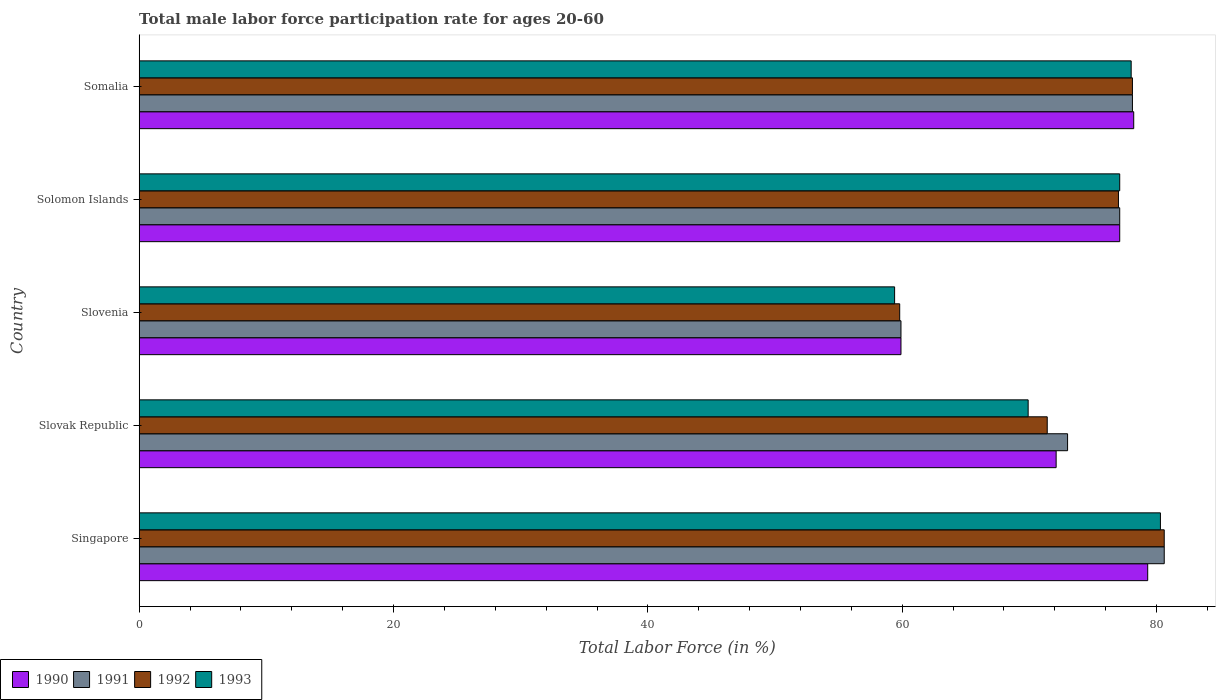How many different coloured bars are there?
Give a very brief answer. 4. Are the number of bars per tick equal to the number of legend labels?
Your answer should be very brief. Yes. Are the number of bars on each tick of the Y-axis equal?
Offer a terse response. Yes. How many bars are there on the 1st tick from the bottom?
Provide a succinct answer. 4. What is the label of the 4th group of bars from the top?
Your answer should be very brief. Slovak Republic. In how many cases, is the number of bars for a given country not equal to the number of legend labels?
Make the answer very short. 0. What is the male labor force participation rate in 1990 in Somalia?
Provide a short and direct response. 78.2. Across all countries, what is the maximum male labor force participation rate in 1993?
Give a very brief answer. 80.3. Across all countries, what is the minimum male labor force participation rate in 1990?
Your response must be concise. 59.9. In which country was the male labor force participation rate in 1990 maximum?
Keep it short and to the point. Singapore. In which country was the male labor force participation rate in 1990 minimum?
Give a very brief answer. Slovenia. What is the total male labor force participation rate in 1991 in the graph?
Ensure brevity in your answer.  368.7. What is the difference between the male labor force participation rate in 1992 in Slovak Republic and that in Solomon Islands?
Give a very brief answer. -5.6. What is the difference between the male labor force participation rate in 1991 in Solomon Islands and the male labor force participation rate in 1993 in Singapore?
Your response must be concise. -3.2. What is the average male labor force participation rate in 1990 per country?
Offer a very short reply. 73.32. What is the difference between the male labor force participation rate in 1993 and male labor force participation rate in 1990 in Somalia?
Offer a very short reply. -0.2. In how many countries, is the male labor force participation rate in 1993 greater than 56 %?
Your answer should be compact. 5. What is the ratio of the male labor force participation rate in 1992 in Singapore to that in Slovenia?
Keep it short and to the point. 1.35. What is the difference between the highest and the second highest male labor force participation rate in 1993?
Offer a terse response. 2.3. What is the difference between the highest and the lowest male labor force participation rate in 1992?
Your answer should be compact. 20.8. Is it the case that in every country, the sum of the male labor force participation rate in 1990 and male labor force participation rate in 1991 is greater than the sum of male labor force participation rate in 1993 and male labor force participation rate in 1992?
Provide a short and direct response. No. What does the 1st bar from the top in Somalia represents?
Your answer should be compact. 1993. What does the 2nd bar from the bottom in Slovak Republic represents?
Ensure brevity in your answer.  1991. How many bars are there?
Give a very brief answer. 20. Are all the bars in the graph horizontal?
Keep it short and to the point. Yes. What is the difference between two consecutive major ticks on the X-axis?
Ensure brevity in your answer.  20. Does the graph contain any zero values?
Make the answer very short. No. Does the graph contain grids?
Your response must be concise. No. What is the title of the graph?
Provide a succinct answer. Total male labor force participation rate for ages 20-60. What is the label or title of the X-axis?
Keep it short and to the point. Total Labor Force (in %). What is the Total Labor Force (in %) of 1990 in Singapore?
Provide a succinct answer. 79.3. What is the Total Labor Force (in %) in 1991 in Singapore?
Offer a terse response. 80.6. What is the Total Labor Force (in %) of 1992 in Singapore?
Provide a succinct answer. 80.6. What is the Total Labor Force (in %) of 1993 in Singapore?
Offer a terse response. 80.3. What is the Total Labor Force (in %) of 1990 in Slovak Republic?
Offer a terse response. 72.1. What is the Total Labor Force (in %) of 1992 in Slovak Republic?
Offer a very short reply. 71.4. What is the Total Labor Force (in %) of 1993 in Slovak Republic?
Offer a very short reply. 69.9. What is the Total Labor Force (in %) of 1990 in Slovenia?
Offer a very short reply. 59.9. What is the Total Labor Force (in %) in 1991 in Slovenia?
Give a very brief answer. 59.9. What is the Total Labor Force (in %) of 1992 in Slovenia?
Provide a succinct answer. 59.8. What is the Total Labor Force (in %) of 1993 in Slovenia?
Provide a short and direct response. 59.4. What is the Total Labor Force (in %) of 1990 in Solomon Islands?
Give a very brief answer. 77.1. What is the Total Labor Force (in %) in 1991 in Solomon Islands?
Offer a very short reply. 77.1. What is the Total Labor Force (in %) in 1993 in Solomon Islands?
Offer a terse response. 77.1. What is the Total Labor Force (in %) in 1990 in Somalia?
Offer a very short reply. 78.2. What is the Total Labor Force (in %) in 1991 in Somalia?
Give a very brief answer. 78.1. What is the Total Labor Force (in %) in 1992 in Somalia?
Your answer should be compact. 78.1. Across all countries, what is the maximum Total Labor Force (in %) in 1990?
Offer a terse response. 79.3. Across all countries, what is the maximum Total Labor Force (in %) in 1991?
Keep it short and to the point. 80.6. Across all countries, what is the maximum Total Labor Force (in %) in 1992?
Keep it short and to the point. 80.6. Across all countries, what is the maximum Total Labor Force (in %) in 1993?
Make the answer very short. 80.3. Across all countries, what is the minimum Total Labor Force (in %) of 1990?
Your answer should be very brief. 59.9. Across all countries, what is the minimum Total Labor Force (in %) in 1991?
Make the answer very short. 59.9. Across all countries, what is the minimum Total Labor Force (in %) of 1992?
Your answer should be compact. 59.8. Across all countries, what is the minimum Total Labor Force (in %) of 1993?
Your answer should be compact. 59.4. What is the total Total Labor Force (in %) of 1990 in the graph?
Your response must be concise. 366.6. What is the total Total Labor Force (in %) of 1991 in the graph?
Make the answer very short. 368.7. What is the total Total Labor Force (in %) in 1992 in the graph?
Ensure brevity in your answer.  366.9. What is the total Total Labor Force (in %) of 1993 in the graph?
Your answer should be very brief. 364.7. What is the difference between the Total Labor Force (in %) of 1991 in Singapore and that in Slovak Republic?
Make the answer very short. 7.6. What is the difference between the Total Labor Force (in %) of 1992 in Singapore and that in Slovak Republic?
Keep it short and to the point. 9.2. What is the difference between the Total Labor Force (in %) of 1993 in Singapore and that in Slovak Republic?
Your answer should be very brief. 10.4. What is the difference between the Total Labor Force (in %) of 1991 in Singapore and that in Slovenia?
Provide a short and direct response. 20.7. What is the difference between the Total Labor Force (in %) of 1992 in Singapore and that in Slovenia?
Give a very brief answer. 20.8. What is the difference between the Total Labor Force (in %) of 1993 in Singapore and that in Slovenia?
Make the answer very short. 20.9. What is the difference between the Total Labor Force (in %) in 1992 in Singapore and that in Somalia?
Give a very brief answer. 2.5. What is the difference between the Total Labor Force (in %) of 1990 in Slovak Republic and that in Solomon Islands?
Give a very brief answer. -5. What is the difference between the Total Labor Force (in %) of 1991 in Slovak Republic and that in Solomon Islands?
Keep it short and to the point. -4.1. What is the difference between the Total Labor Force (in %) of 1991 in Slovak Republic and that in Somalia?
Your response must be concise. -5.1. What is the difference between the Total Labor Force (in %) in 1990 in Slovenia and that in Solomon Islands?
Give a very brief answer. -17.2. What is the difference between the Total Labor Force (in %) of 1991 in Slovenia and that in Solomon Islands?
Ensure brevity in your answer.  -17.2. What is the difference between the Total Labor Force (in %) of 1992 in Slovenia and that in Solomon Islands?
Ensure brevity in your answer.  -17.2. What is the difference between the Total Labor Force (in %) in 1993 in Slovenia and that in Solomon Islands?
Offer a terse response. -17.7. What is the difference between the Total Labor Force (in %) in 1990 in Slovenia and that in Somalia?
Your response must be concise. -18.3. What is the difference between the Total Labor Force (in %) of 1991 in Slovenia and that in Somalia?
Keep it short and to the point. -18.2. What is the difference between the Total Labor Force (in %) in 1992 in Slovenia and that in Somalia?
Your answer should be very brief. -18.3. What is the difference between the Total Labor Force (in %) in 1993 in Slovenia and that in Somalia?
Offer a terse response. -18.6. What is the difference between the Total Labor Force (in %) in 1990 in Solomon Islands and that in Somalia?
Your answer should be compact. -1.1. What is the difference between the Total Labor Force (in %) in 1992 in Solomon Islands and that in Somalia?
Provide a short and direct response. -1.1. What is the difference between the Total Labor Force (in %) in 1990 in Singapore and the Total Labor Force (in %) in 1993 in Slovak Republic?
Make the answer very short. 9.4. What is the difference between the Total Labor Force (in %) in 1991 in Singapore and the Total Labor Force (in %) in 1993 in Slovak Republic?
Your response must be concise. 10.7. What is the difference between the Total Labor Force (in %) in 1992 in Singapore and the Total Labor Force (in %) in 1993 in Slovak Republic?
Keep it short and to the point. 10.7. What is the difference between the Total Labor Force (in %) in 1990 in Singapore and the Total Labor Force (in %) in 1992 in Slovenia?
Give a very brief answer. 19.5. What is the difference between the Total Labor Force (in %) in 1991 in Singapore and the Total Labor Force (in %) in 1992 in Slovenia?
Give a very brief answer. 20.8. What is the difference between the Total Labor Force (in %) in 1991 in Singapore and the Total Labor Force (in %) in 1993 in Slovenia?
Your response must be concise. 21.2. What is the difference between the Total Labor Force (in %) in 1992 in Singapore and the Total Labor Force (in %) in 1993 in Slovenia?
Keep it short and to the point. 21.2. What is the difference between the Total Labor Force (in %) of 1990 in Singapore and the Total Labor Force (in %) of 1991 in Solomon Islands?
Give a very brief answer. 2.2. What is the difference between the Total Labor Force (in %) of 1990 in Singapore and the Total Labor Force (in %) of 1992 in Solomon Islands?
Offer a very short reply. 2.3. What is the difference between the Total Labor Force (in %) of 1990 in Singapore and the Total Labor Force (in %) of 1993 in Solomon Islands?
Provide a succinct answer. 2.2. What is the difference between the Total Labor Force (in %) of 1990 in Singapore and the Total Labor Force (in %) of 1992 in Somalia?
Ensure brevity in your answer.  1.2. What is the difference between the Total Labor Force (in %) of 1990 in Singapore and the Total Labor Force (in %) of 1993 in Somalia?
Your response must be concise. 1.3. What is the difference between the Total Labor Force (in %) of 1991 in Singapore and the Total Labor Force (in %) of 1992 in Somalia?
Keep it short and to the point. 2.5. What is the difference between the Total Labor Force (in %) of 1992 in Singapore and the Total Labor Force (in %) of 1993 in Somalia?
Your answer should be very brief. 2.6. What is the difference between the Total Labor Force (in %) in 1990 in Slovak Republic and the Total Labor Force (in %) in 1991 in Slovenia?
Ensure brevity in your answer.  12.2. What is the difference between the Total Labor Force (in %) of 1991 in Slovak Republic and the Total Labor Force (in %) of 1993 in Slovenia?
Keep it short and to the point. 13.6. What is the difference between the Total Labor Force (in %) in 1992 in Slovak Republic and the Total Labor Force (in %) in 1993 in Slovenia?
Offer a terse response. 12. What is the difference between the Total Labor Force (in %) of 1990 in Slovak Republic and the Total Labor Force (in %) of 1992 in Solomon Islands?
Keep it short and to the point. -4.9. What is the difference between the Total Labor Force (in %) in 1990 in Slovak Republic and the Total Labor Force (in %) in 1993 in Solomon Islands?
Make the answer very short. -5. What is the difference between the Total Labor Force (in %) in 1991 in Slovak Republic and the Total Labor Force (in %) in 1992 in Solomon Islands?
Your answer should be very brief. -4. What is the difference between the Total Labor Force (in %) in 1990 in Slovak Republic and the Total Labor Force (in %) in 1993 in Somalia?
Your answer should be compact. -5.9. What is the difference between the Total Labor Force (in %) in 1992 in Slovak Republic and the Total Labor Force (in %) in 1993 in Somalia?
Give a very brief answer. -6.6. What is the difference between the Total Labor Force (in %) in 1990 in Slovenia and the Total Labor Force (in %) in 1991 in Solomon Islands?
Give a very brief answer. -17.2. What is the difference between the Total Labor Force (in %) of 1990 in Slovenia and the Total Labor Force (in %) of 1992 in Solomon Islands?
Keep it short and to the point. -17.1. What is the difference between the Total Labor Force (in %) of 1990 in Slovenia and the Total Labor Force (in %) of 1993 in Solomon Islands?
Provide a succinct answer. -17.2. What is the difference between the Total Labor Force (in %) of 1991 in Slovenia and the Total Labor Force (in %) of 1992 in Solomon Islands?
Your answer should be compact. -17.1. What is the difference between the Total Labor Force (in %) of 1991 in Slovenia and the Total Labor Force (in %) of 1993 in Solomon Islands?
Offer a terse response. -17.2. What is the difference between the Total Labor Force (in %) in 1992 in Slovenia and the Total Labor Force (in %) in 1993 in Solomon Islands?
Offer a very short reply. -17.3. What is the difference between the Total Labor Force (in %) in 1990 in Slovenia and the Total Labor Force (in %) in 1991 in Somalia?
Your answer should be very brief. -18.2. What is the difference between the Total Labor Force (in %) in 1990 in Slovenia and the Total Labor Force (in %) in 1992 in Somalia?
Provide a succinct answer. -18.2. What is the difference between the Total Labor Force (in %) in 1990 in Slovenia and the Total Labor Force (in %) in 1993 in Somalia?
Offer a terse response. -18.1. What is the difference between the Total Labor Force (in %) in 1991 in Slovenia and the Total Labor Force (in %) in 1992 in Somalia?
Ensure brevity in your answer.  -18.2. What is the difference between the Total Labor Force (in %) in 1991 in Slovenia and the Total Labor Force (in %) in 1993 in Somalia?
Provide a short and direct response. -18.1. What is the difference between the Total Labor Force (in %) in 1992 in Slovenia and the Total Labor Force (in %) in 1993 in Somalia?
Make the answer very short. -18.2. What is the difference between the Total Labor Force (in %) in 1990 in Solomon Islands and the Total Labor Force (in %) in 1991 in Somalia?
Make the answer very short. -1. What is the difference between the Total Labor Force (in %) in 1990 in Solomon Islands and the Total Labor Force (in %) in 1992 in Somalia?
Keep it short and to the point. -1. What is the difference between the Total Labor Force (in %) in 1992 in Solomon Islands and the Total Labor Force (in %) in 1993 in Somalia?
Offer a very short reply. -1. What is the average Total Labor Force (in %) in 1990 per country?
Keep it short and to the point. 73.32. What is the average Total Labor Force (in %) in 1991 per country?
Give a very brief answer. 73.74. What is the average Total Labor Force (in %) of 1992 per country?
Offer a very short reply. 73.38. What is the average Total Labor Force (in %) of 1993 per country?
Provide a succinct answer. 72.94. What is the difference between the Total Labor Force (in %) of 1990 and Total Labor Force (in %) of 1992 in Singapore?
Make the answer very short. -1.3. What is the difference between the Total Labor Force (in %) in 1991 and Total Labor Force (in %) in 1992 in Singapore?
Provide a short and direct response. 0. What is the difference between the Total Labor Force (in %) of 1992 and Total Labor Force (in %) of 1993 in Singapore?
Make the answer very short. 0.3. What is the difference between the Total Labor Force (in %) of 1990 and Total Labor Force (in %) of 1993 in Slovak Republic?
Give a very brief answer. 2.2. What is the difference between the Total Labor Force (in %) in 1991 and Total Labor Force (in %) in 1992 in Slovak Republic?
Make the answer very short. 1.6. What is the difference between the Total Labor Force (in %) of 1991 and Total Labor Force (in %) of 1993 in Slovak Republic?
Ensure brevity in your answer.  3.1. What is the difference between the Total Labor Force (in %) of 1992 and Total Labor Force (in %) of 1993 in Slovak Republic?
Your response must be concise. 1.5. What is the difference between the Total Labor Force (in %) in 1990 and Total Labor Force (in %) in 1991 in Slovenia?
Provide a succinct answer. 0. What is the difference between the Total Labor Force (in %) of 1990 and Total Labor Force (in %) of 1992 in Slovenia?
Keep it short and to the point. 0.1. What is the difference between the Total Labor Force (in %) in 1991 and Total Labor Force (in %) in 1992 in Slovenia?
Your response must be concise. 0.1. What is the difference between the Total Labor Force (in %) in 1990 and Total Labor Force (in %) in 1991 in Solomon Islands?
Your answer should be very brief. 0. What is the difference between the Total Labor Force (in %) in 1990 and Total Labor Force (in %) in 1992 in Solomon Islands?
Your answer should be very brief. 0.1. What is the difference between the Total Labor Force (in %) of 1990 and Total Labor Force (in %) of 1993 in Solomon Islands?
Your answer should be very brief. 0. What is the difference between the Total Labor Force (in %) in 1991 and Total Labor Force (in %) in 1992 in Solomon Islands?
Provide a succinct answer. 0.1. What is the difference between the Total Labor Force (in %) of 1991 and Total Labor Force (in %) of 1993 in Solomon Islands?
Offer a very short reply. 0. What is the difference between the Total Labor Force (in %) in 1990 and Total Labor Force (in %) in 1991 in Somalia?
Provide a short and direct response. 0.1. What is the difference between the Total Labor Force (in %) in 1990 and Total Labor Force (in %) in 1993 in Somalia?
Offer a terse response. 0.2. What is the difference between the Total Labor Force (in %) in 1991 and Total Labor Force (in %) in 1993 in Somalia?
Your answer should be compact. 0.1. What is the difference between the Total Labor Force (in %) of 1992 and Total Labor Force (in %) of 1993 in Somalia?
Give a very brief answer. 0.1. What is the ratio of the Total Labor Force (in %) of 1990 in Singapore to that in Slovak Republic?
Offer a terse response. 1.1. What is the ratio of the Total Labor Force (in %) in 1991 in Singapore to that in Slovak Republic?
Your answer should be compact. 1.1. What is the ratio of the Total Labor Force (in %) of 1992 in Singapore to that in Slovak Republic?
Provide a succinct answer. 1.13. What is the ratio of the Total Labor Force (in %) in 1993 in Singapore to that in Slovak Republic?
Your answer should be very brief. 1.15. What is the ratio of the Total Labor Force (in %) of 1990 in Singapore to that in Slovenia?
Provide a short and direct response. 1.32. What is the ratio of the Total Labor Force (in %) of 1991 in Singapore to that in Slovenia?
Give a very brief answer. 1.35. What is the ratio of the Total Labor Force (in %) in 1992 in Singapore to that in Slovenia?
Offer a very short reply. 1.35. What is the ratio of the Total Labor Force (in %) of 1993 in Singapore to that in Slovenia?
Give a very brief answer. 1.35. What is the ratio of the Total Labor Force (in %) in 1990 in Singapore to that in Solomon Islands?
Make the answer very short. 1.03. What is the ratio of the Total Labor Force (in %) in 1991 in Singapore to that in Solomon Islands?
Make the answer very short. 1.05. What is the ratio of the Total Labor Force (in %) in 1992 in Singapore to that in Solomon Islands?
Your answer should be compact. 1.05. What is the ratio of the Total Labor Force (in %) in 1993 in Singapore to that in Solomon Islands?
Keep it short and to the point. 1.04. What is the ratio of the Total Labor Force (in %) in 1990 in Singapore to that in Somalia?
Offer a very short reply. 1.01. What is the ratio of the Total Labor Force (in %) in 1991 in Singapore to that in Somalia?
Provide a succinct answer. 1.03. What is the ratio of the Total Labor Force (in %) of 1992 in Singapore to that in Somalia?
Keep it short and to the point. 1.03. What is the ratio of the Total Labor Force (in %) of 1993 in Singapore to that in Somalia?
Offer a terse response. 1.03. What is the ratio of the Total Labor Force (in %) in 1990 in Slovak Republic to that in Slovenia?
Your answer should be compact. 1.2. What is the ratio of the Total Labor Force (in %) in 1991 in Slovak Republic to that in Slovenia?
Keep it short and to the point. 1.22. What is the ratio of the Total Labor Force (in %) of 1992 in Slovak Republic to that in Slovenia?
Provide a succinct answer. 1.19. What is the ratio of the Total Labor Force (in %) of 1993 in Slovak Republic to that in Slovenia?
Your response must be concise. 1.18. What is the ratio of the Total Labor Force (in %) in 1990 in Slovak Republic to that in Solomon Islands?
Offer a very short reply. 0.94. What is the ratio of the Total Labor Force (in %) in 1991 in Slovak Republic to that in Solomon Islands?
Keep it short and to the point. 0.95. What is the ratio of the Total Labor Force (in %) in 1992 in Slovak Republic to that in Solomon Islands?
Ensure brevity in your answer.  0.93. What is the ratio of the Total Labor Force (in %) of 1993 in Slovak Republic to that in Solomon Islands?
Your answer should be compact. 0.91. What is the ratio of the Total Labor Force (in %) of 1990 in Slovak Republic to that in Somalia?
Your answer should be very brief. 0.92. What is the ratio of the Total Labor Force (in %) in 1991 in Slovak Republic to that in Somalia?
Provide a short and direct response. 0.93. What is the ratio of the Total Labor Force (in %) of 1992 in Slovak Republic to that in Somalia?
Ensure brevity in your answer.  0.91. What is the ratio of the Total Labor Force (in %) in 1993 in Slovak Republic to that in Somalia?
Offer a very short reply. 0.9. What is the ratio of the Total Labor Force (in %) in 1990 in Slovenia to that in Solomon Islands?
Your response must be concise. 0.78. What is the ratio of the Total Labor Force (in %) of 1991 in Slovenia to that in Solomon Islands?
Offer a very short reply. 0.78. What is the ratio of the Total Labor Force (in %) in 1992 in Slovenia to that in Solomon Islands?
Ensure brevity in your answer.  0.78. What is the ratio of the Total Labor Force (in %) in 1993 in Slovenia to that in Solomon Islands?
Offer a very short reply. 0.77. What is the ratio of the Total Labor Force (in %) of 1990 in Slovenia to that in Somalia?
Your response must be concise. 0.77. What is the ratio of the Total Labor Force (in %) in 1991 in Slovenia to that in Somalia?
Give a very brief answer. 0.77. What is the ratio of the Total Labor Force (in %) of 1992 in Slovenia to that in Somalia?
Give a very brief answer. 0.77. What is the ratio of the Total Labor Force (in %) of 1993 in Slovenia to that in Somalia?
Keep it short and to the point. 0.76. What is the ratio of the Total Labor Force (in %) in 1990 in Solomon Islands to that in Somalia?
Ensure brevity in your answer.  0.99. What is the ratio of the Total Labor Force (in %) in 1991 in Solomon Islands to that in Somalia?
Offer a very short reply. 0.99. What is the ratio of the Total Labor Force (in %) in 1992 in Solomon Islands to that in Somalia?
Your response must be concise. 0.99. What is the ratio of the Total Labor Force (in %) in 1993 in Solomon Islands to that in Somalia?
Your answer should be very brief. 0.99. What is the difference between the highest and the second highest Total Labor Force (in %) in 1990?
Your answer should be very brief. 1.1. What is the difference between the highest and the second highest Total Labor Force (in %) in 1993?
Your response must be concise. 2.3. What is the difference between the highest and the lowest Total Labor Force (in %) in 1990?
Ensure brevity in your answer.  19.4. What is the difference between the highest and the lowest Total Labor Force (in %) of 1991?
Give a very brief answer. 20.7. What is the difference between the highest and the lowest Total Labor Force (in %) in 1992?
Make the answer very short. 20.8. What is the difference between the highest and the lowest Total Labor Force (in %) in 1993?
Give a very brief answer. 20.9. 